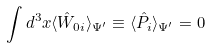<formula> <loc_0><loc_0><loc_500><loc_500>\int d ^ { 3 } x \langle \hat { W } _ { 0 i } \rangle _ { \Psi ^ { \prime } } \equiv \langle { \hat { P } _ { i } } \rangle _ { \Psi ^ { \prime } } = 0</formula> 